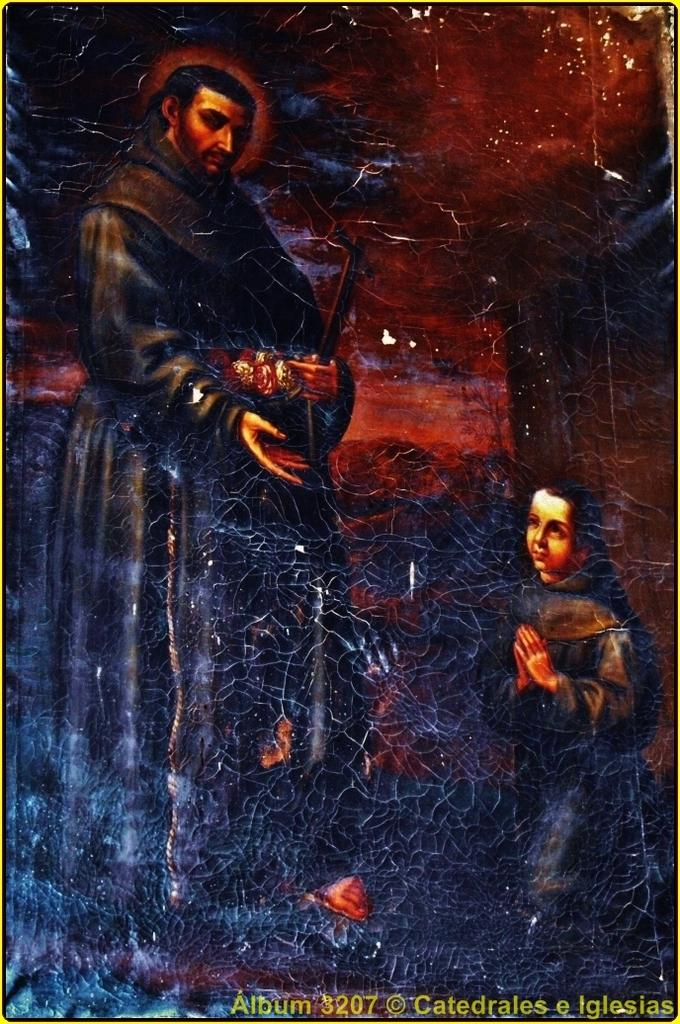<image>
Describe the image concisely. Man standing with child praying from Album 3207 Catedrales e Iglesias. 